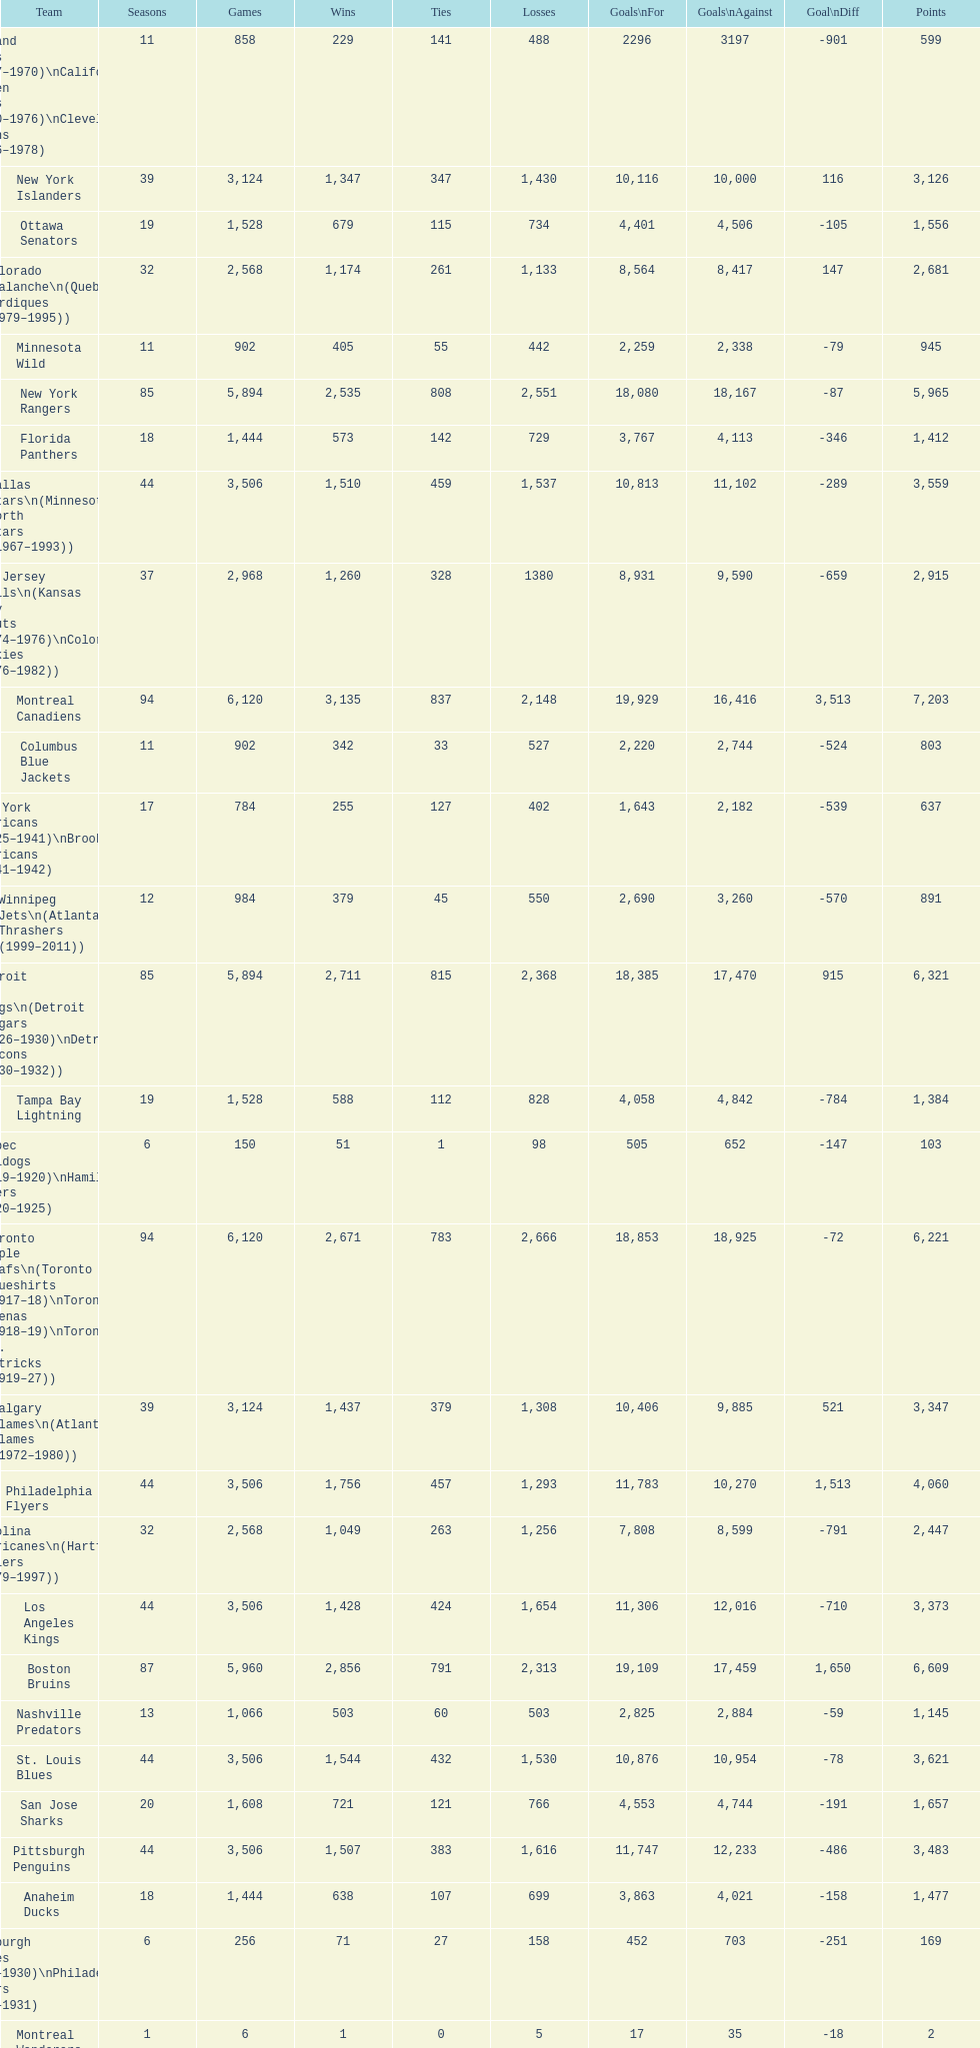Give me the full table as a dictionary. {'header': ['Team', 'Seasons', 'Games', 'Wins', 'Ties', 'Losses', 'Goals\\nFor', 'Goals\\nAgainst', 'Goal\\nDiff', 'Points'], 'rows': [['Oakland Seals (1967–1970)\\nCalifornia Golden Seals (1970–1976)\\nCleveland Barons (1976–1978)', '11', '858', '229', '141', '488', '2296', '3197', '-901', '599'], ['New York Islanders', '39', '3,124', '1,347', '347', '1,430', '10,116', '10,000', '116', '3,126'], ['Ottawa Senators', '19', '1,528', '679', '115', '734', '4,401', '4,506', '-105', '1,556'], ['Colorado Avalanche\\n(Quebec Nordiques (1979–1995))', '32', '2,568', '1,174', '261', '1,133', '8,564', '8,417', '147', '2,681'], ['Minnesota Wild', '11', '902', '405', '55', '442', '2,259', '2,338', '-79', '945'], ['New York Rangers', '85', '5,894', '2,535', '808', '2,551', '18,080', '18,167', '-87', '5,965'], ['Florida Panthers', '18', '1,444', '573', '142', '729', '3,767', '4,113', '-346', '1,412'], ['Dallas Stars\\n(Minnesota North Stars (1967–1993))', '44', '3,506', '1,510', '459', '1,537', '10,813', '11,102', '-289', '3,559'], ['New Jersey Devils\\n(Kansas City Scouts (1974–1976)\\nColorado Rockies (1976–1982))', '37', '2,968', '1,260', '328', '1380', '8,931', '9,590', '-659', '2,915'], ['Montreal Canadiens', '94', '6,120', '3,135', '837', '2,148', '19,929', '16,416', '3,513', '7,203'], ['Columbus Blue Jackets', '11', '902', '342', '33', '527', '2,220', '2,744', '-524', '803'], ['New York Americans (1925–1941)\\nBrooklyn Americans (1941–1942)', '17', '784', '255', '127', '402', '1,643', '2,182', '-539', '637'], ['Winnipeg Jets\\n(Atlanta Thrashers (1999–2011))', '12', '984', '379', '45', '550', '2,690', '3,260', '-570', '891'], ['Detroit Red Wings\\n(Detroit Cougars (1926–1930)\\nDetroit Falcons (1930–1932))', '85', '5,894', '2,711', '815', '2,368', '18,385', '17,470', '915', '6,321'], ['Tampa Bay Lightning', '19', '1,528', '588', '112', '828', '4,058', '4,842', '-784', '1,384'], ['Quebec Bulldogs (1919–1920)\\nHamilton Tigers (1920–1925)', '6', '150', '51', '1', '98', '505', '652', '-147', '103'], ['Toronto Maple Leafs\\n(Toronto Blueshirts (1917–18)\\nToronto Arenas (1918–19)\\nToronto St. Patricks (1919–27))', '94', '6,120', '2,671', '783', '2,666', '18,853', '18,925', '-72', '6,221'], ['Calgary Flames\\n(Atlanta Flames (1972–1980))', '39', '3,124', '1,437', '379', '1,308', '10,406', '9,885', '521', '3,347'], ['Philadelphia Flyers', '44', '3,506', '1,756', '457', '1,293', '11,783', '10,270', '1,513', '4,060'], ['Carolina Hurricanes\\n(Hartford Whalers (1979–1997))', '32', '2,568', '1,049', '263', '1,256', '7,808', '8,599', '-791', '2,447'], ['Los Angeles Kings', '44', '3,506', '1,428', '424', '1,654', '11,306', '12,016', '-710', '3,373'], ['Boston Bruins', '87', '5,960', '2,856', '791', '2,313', '19,109', '17,459', '1,650', '6,609'], ['Nashville Predators', '13', '1,066', '503', '60', '503', '2,825', '2,884', '-59', '1,145'], ['St. Louis Blues', '44', '3,506', '1,544', '432', '1,530', '10,876', '10,954', '-78', '3,621'], ['San Jose Sharks', '20', '1,608', '721', '121', '766', '4,553', '4,744', '-191', '1,657'], ['Pittsburgh Penguins', '44', '3,506', '1,507', '383', '1,616', '11,747', '12,233', '-486', '3,483'], ['Anaheim Ducks', '18', '1,444', '638', '107', '699', '3,863', '4,021', '-158', '1,477'], ['Pittsburgh Pirates (1925–1930)\\nPhiladelphia Quakers (1930–1931)', '6', '256', '71', '27', '158', '452', '703', '-251', '169'], ['Montreal Wanderers', '1', '6', '1', '0', '5', '17', '35', '-18', '2'], ['Buffalo Sabres', '41', '3,280', '1,569', '409', '1,302', '10,868', '9,875', '993', '3,630'], ['Vancouver Canucks', '41', '3,280', '1,353', '391', '1,536', '10,378', '1,1024', '-646', '3,179'], ['Montreal Maroons', '14', '622', '271', '91', '260', '1,474', '1,405', '69', '633'], ['Chicago Blackhawks', '85', '5,894', '2,460', '814', '2,620', '17,535', '17,802', '-267', '5,826'], ['Edmonton Oilers', '32', '2,568', '1,176', '262', '1,130', '8,926', '8,581', '345', '2,708'], ['Washington Capitals', '37', '2,968', '1,305', '303', '1,360', '9,407', '9,739', '-332', '3,004'], ['Ottawa Senators (1917–1934)\\nSt. Louis Eagles (1934–1935)', '17', '590', '269', '69', '252', '1,544', '1,478', '66', '607'], ['Phoenix Coyotes\\n(Winnipeg Jets (1979–1996))', '32', '2,568', '1,063', '266', '1,239', '8,058', '8,809', '-756', '2,473']]} What is the number of losses for the st. louis blues? 1,530. 